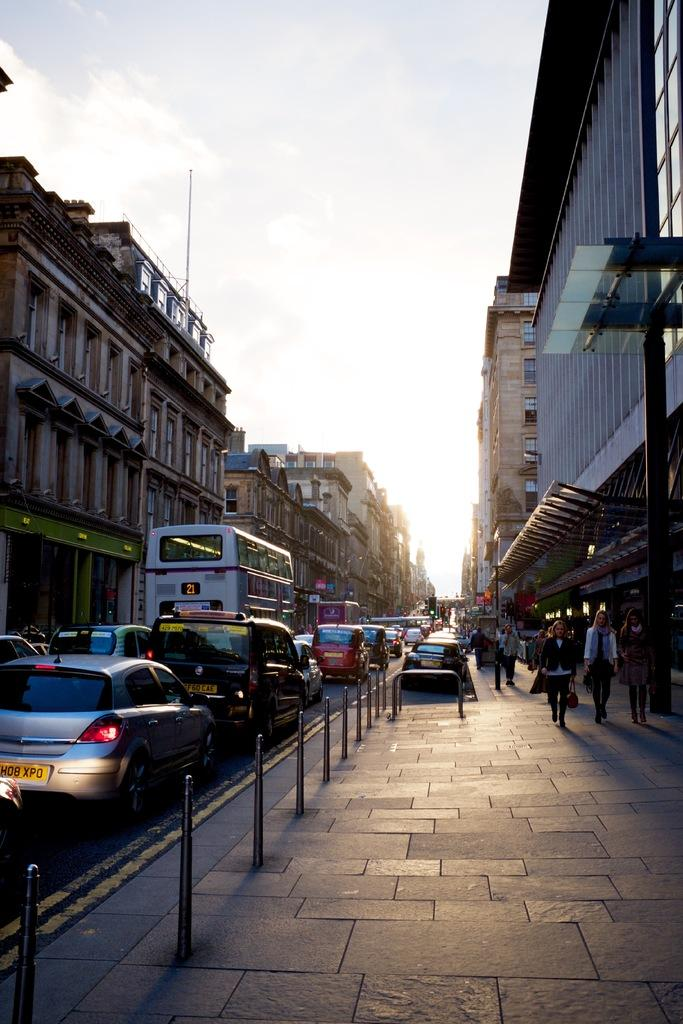<image>
Summarize the visual content of the image. A large bus drives down a busy street, it's bus number 21. 